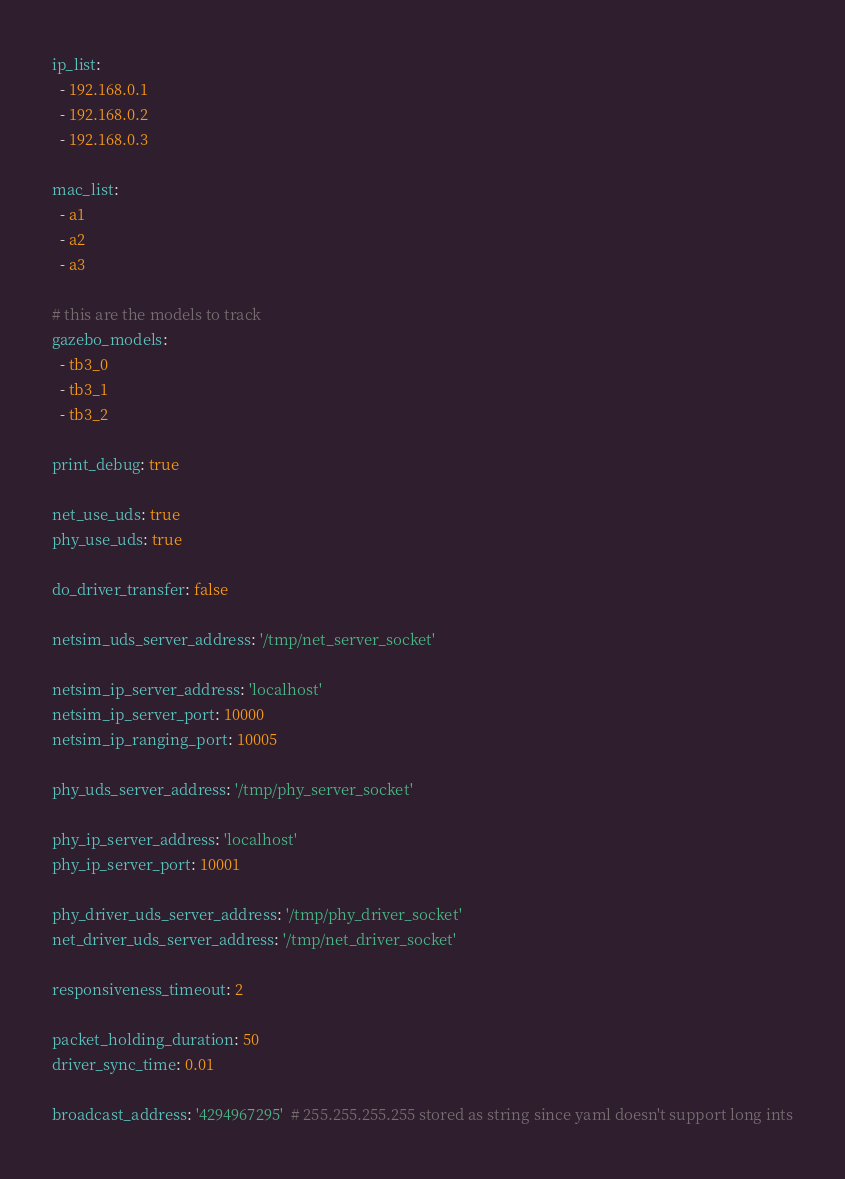<code> <loc_0><loc_0><loc_500><loc_500><_YAML_>ip_list:
  - 192.168.0.1
  - 192.168.0.2
  - 192.168.0.3

mac_list:
  - a1
  - a2
  - a3

# this are the models to track
gazebo_models:
  - tb3_0
  - tb3_1
  - tb3_2

print_debug: true

net_use_uds: true
phy_use_uds: true

do_driver_transfer: false

netsim_uds_server_address: '/tmp/net_server_socket'

netsim_ip_server_address: 'localhost'
netsim_ip_server_port: 10000
netsim_ip_ranging_port: 10005

phy_uds_server_address: '/tmp/phy_server_socket'

phy_ip_server_address: 'localhost'
phy_ip_server_port: 10001

phy_driver_uds_server_address: '/tmp/phy_driver_socket'
net_driver_uds_server_address: '/tmp/net_driver_socket'

responsiveness_timeout: 2

packet_holding_duration: 50
driver_sync_time: 0.01

broadcast_address: '4294967295'  # 255.255.255.255 stored as string since yaml doesn't support long ints
</code> 